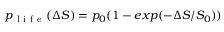Convert formula to latex. <formula><loc_0><loc_0><loc_500><loc_500>p _ { l i f e } ( \Delta S ) = p _ { 0 } ( 1 - e x p ( - \Delta S / S _ { 0 } ) )</formula> 